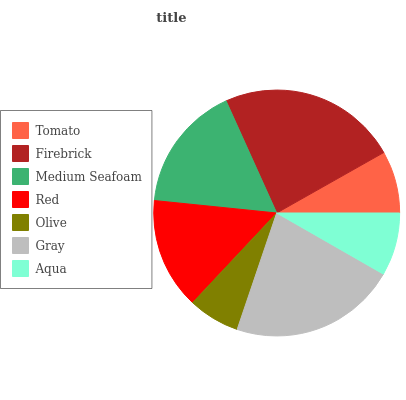Is Olive the minimum?
Answer yes or no. Yes. Is Firebrick the maximum?
Answer yes or no. Yes. Is Medium Seafoam the minimum?
Answer yes or no. No. Is Medium Seafoam the maximum?
Answer yes or no. No. Is Firebrick greater than Medium Seafoam?
Answer yes or no. Yes. Is Medium Seafoam less than Firebrick?
Answer yes or no. Yes. Is Medium Seafoam greater than Firebrick?
Answer yes or no. No. Is Firebrick less than Medium Seafoam?
Answer yes or no. No. Is Red the high median?
Answer yes or no. Yes. Is Red the low median?
Answer yes or no. Yes. Is Aqua the high median?
Answer yes or no. No. Is Gray the low median?
Answer yes or no. No. 